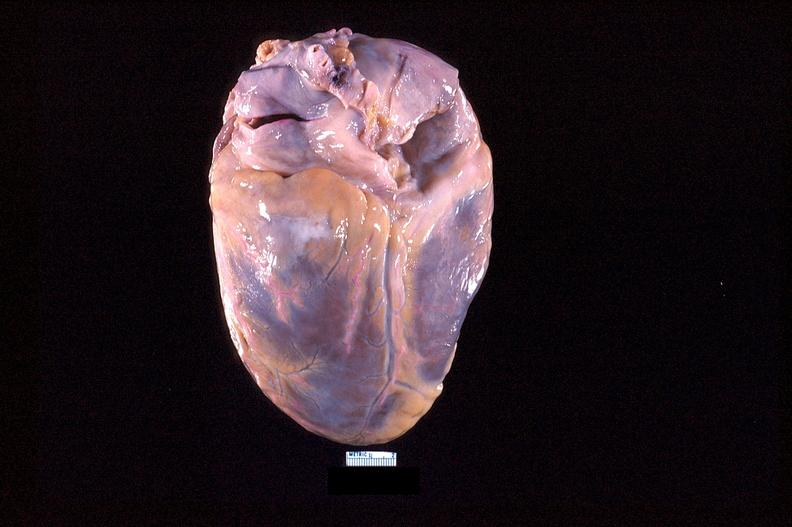does myocardium show heart, posterior surface, acute posterior myocardial infarction?
Answer the question using a single word or phrase. No 